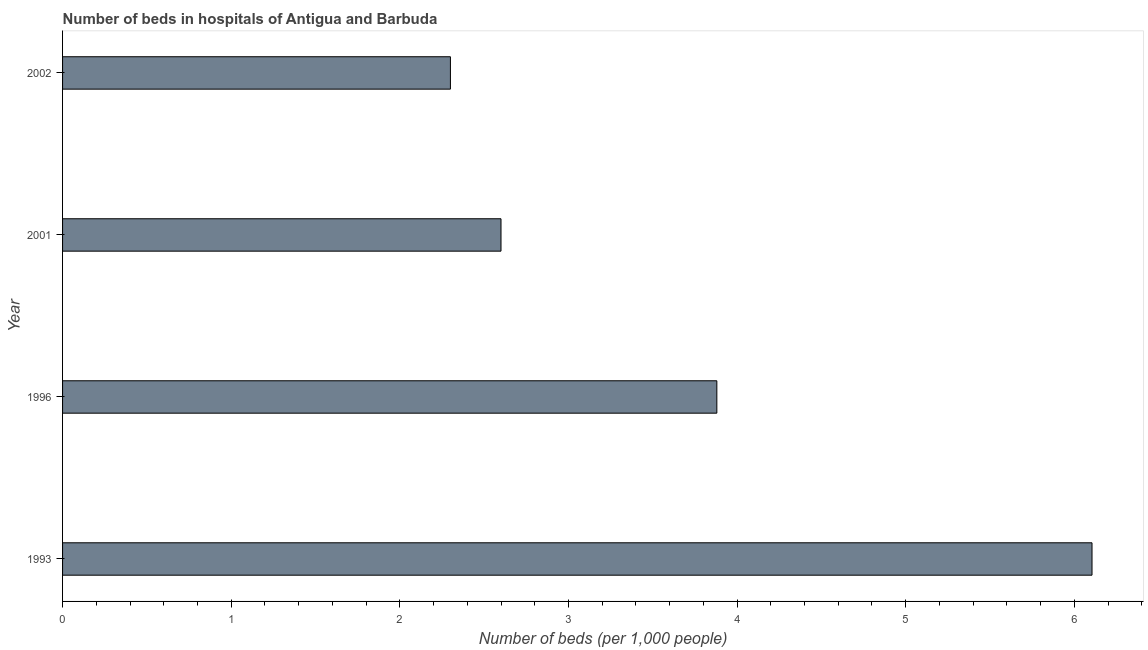Does the graph contain any zero values?
Provide a succinct answer. No. Does the graph contain grids?
Give a very brief answer. No. What is the title of the graph?
Your answer should be compact. Number of beds in hospitals of Antigua and Barbuda. What is the label or title of the X-axis?
Ensure brevity in your answer.  Number of beds (per 1,0 people). What is the number of hospital beds in 1996?
Give a very brief answer. 3.88. Across all years, what is the maximum number of hospital beds?
Your answer should be very brief. 6.1. Across all years, what is the minimum number of hospital beds?
Ensure brevity in your answer.  2.3. In which year was the number of hospital beds maximum?
Provide a short and direct response. 1993. What is the sum of the number of hospital beds?
Provide a succinct answer. 14.88. What is the difference between the number of hospital beds in 1993 and 1996?
Your answer should be compact. 2.23. What is the average number of hospital beds per year?
Your response must be concise. 3.72. What is the median number of hospital beds?
Make the answer very short. 3.24. What is the ratio of the number of hospital beds in 1996 to that in 2001?
Give a very brief answer. 1.49. What is the difference between the highest and the second highest number of hospital beds?
Your answer should be compact. 2.23. Is the sum of the number of hospital beds in 1993 and 1996 greater than the maximum number of hospital beds across all years?
Provide a short and direct response. Yes. Are all the bars in the graph horizontal?
Offer a very short reply. Yes. How many years are there in the graph?
Offer a very short reply. 4. Are the values on the major ticks of X-axis written in scientific E-notation?
Provide a succinct answer. No. What is the Number of beds (per 1,000 people) of 1993?
Your response must be concise. 6.1. What is the Number of beds (per 1,000 people) of 1996?
Offer a very short reply. 3.88. What is the difference between the Number of beds (per 1,000 people) in 1993 and 1996?
Your answer should be very brief. 2.22. What is the difference between the Number of beds (per 1,000 people) in 1993 and 2001?
Provide a succinct answer. 3.5. What is the difference between the Number of beds (per 1,000 people) in 1993 and 2002?
Your answer should be very brief. 3.8. What is the difference between the Number of beds (per 1,000 people) in 1996 and 2001?
Offer a very short reply. 1.28. What is the difference between the Number of beds (per 1,000 people) in 1996 and 2002?
Provide a short and direct response. 1.58. What is the ratio of the Number of beds (per 1,000 people) in 1993 to that in 1996?
Your answer should be compact. 1.57. What is the ratio of the Number of beds (per 1,000 people) in 1993 to that in 2001?
Your answer should be very brief. 2.35. What is the ratio of the Number of beds (per 1,000 people) in 1993 to that in 2002?
Your answer should be very brief. 2.65. What is the ratio of the Number of beds (per 1,000 people) in 1996 to that in 2001?
Provide a succinct answer. 1.49. What is the ratio of the Number of beds (per 1,000 people) in 1996 to that in 2002?
Your answer should be very brief. 1.69. What is the ratio of the Number of beds (per 1,000 people) in 2001 to that in 2002?
Your answer should be compact. 1.13. 